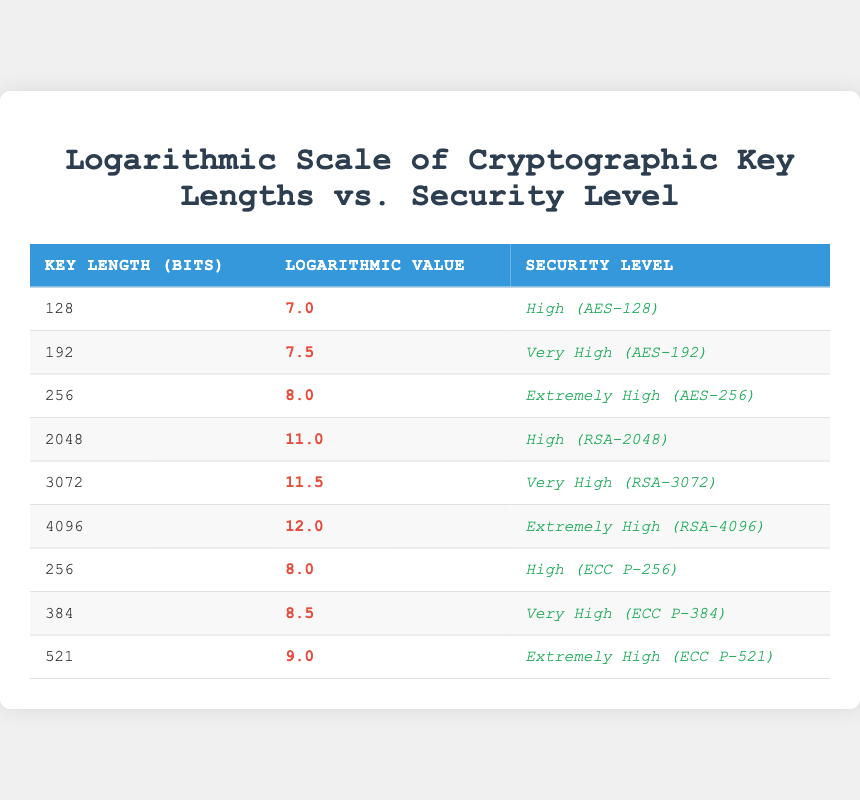What is the security level of a key length of 128 bits? According to the table, a key length of 128 bits is categorized as "High (AES-128)."
Answer: High (AES-128) What is the logarithmic value for the RSA-2048 key length? The table shows that the logarithmic value associated with RSA-2048, which has a key length of 2048 bits, is 11.0.
Answer: 11.0 How many key lengths have a security level labeled as 'Extremely High'? By counting the rows with the security level 'Extremely High,' we find three instances: AES-256, RSA-4096, and ECC P-521.
Answer: 3 What is the average logarithmic value for key lengths that are categorized as "Very High"? The average logarithmic value for key lengths categorized as "Very High" (AES-192, RSA-3072, ECC P-384) is calculated as follows: (7.5 + 11.5 + 8.5) / 3 = 9.5.
Answer: 9.5 Is the logarithmic value of 8.0 associated with a single key length? No, the logarithmic value of 8.0 appears twice in the table, associated with both AES-256 and ECC P-256.
Answer: No Which key length has the highest logarithmic value, and what is its corresponding security level? Referring to the table, the highest logarithmic value is 12.0, which corresponds to a key length of 4096 bits categorized as "Extremely High (RSA-4096)."
Answer: 4096 bits, Extremely High (RSA-4096) What is the difference in logarithmic value between ECC P-521 and AES-256? The logarithmic value for ECC P-521 is 9.0, and for AES-256, it is 8.0. Therefore, the difference is 9.0 - 8.0 = 1.0.
Answer: 1.0 How many unique key lengths are presented for symmetric encryption methods (AES)? The unique key lengths for symmetric encryption methods (AES) in the table are 128, 192, and 256 bits, totaling 3 unique lengths.
Answer: 3 